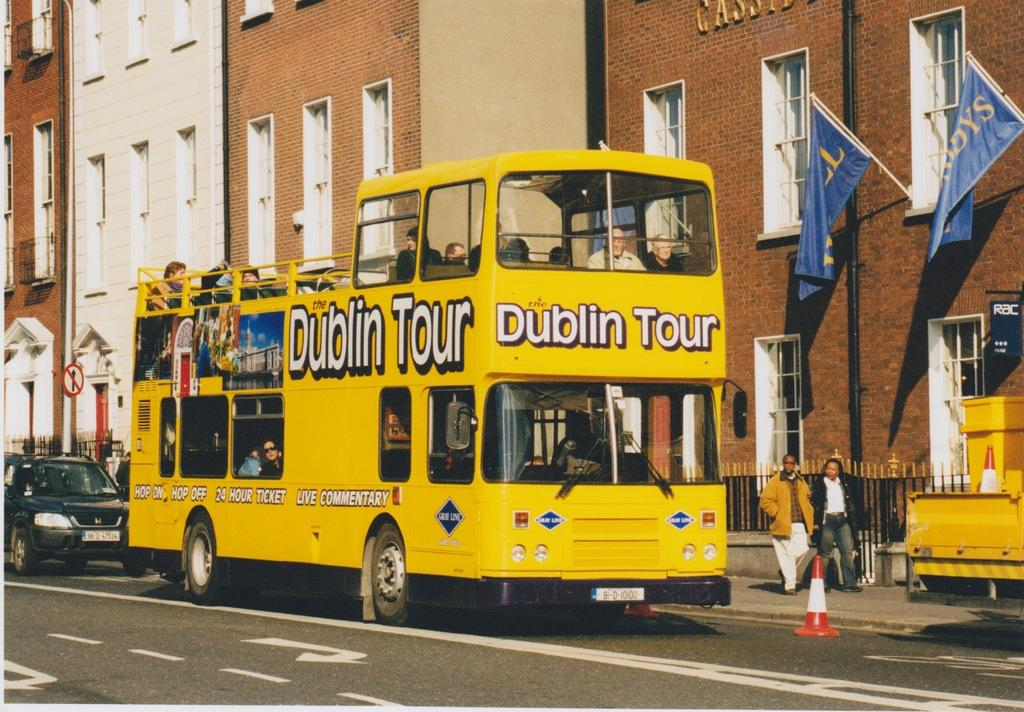Provide a one-sentence caption for the provided image. A yellow double decker Dublin Tour bus on a street. 